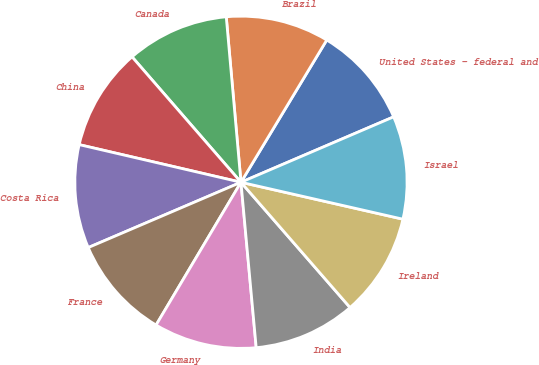Convert chart to OTSL. <chart><loc_0><loc_0><loc_500><loc_500><pie_chart><fcel>United States - federal and<fcel>Brazil<fcel>Canada<fcel>China<fcel>Costa Rica<fcel>France<fcel>Germany<fcel>India<fcel>Ireland<fcel>Israel<nl><fcel>9.92%<fcel>10.05%<fcel>9.97%<fcel>9.98%<fcel>10.07%<fcel>10.03%<fcel>10.0%<fcel>9.94%<fcel>10.03%<fcel>10.01%<nl></chart> 